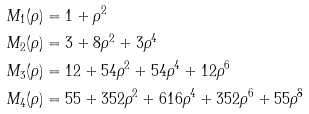Convert formula to latex. <formula><loc_0><loc_0><loc_500><loc_500>M _ { 1 } ( \rho ) & = 1 + \rho ^ { 2 } \\ M _ { 2 } ( \rho ) & = 3 + 8 \rho ^ { 2 } + 3 \rho ^ { 4 } \\ M _ { 3 } ( \rho ) & = 1 2 + 5 4 \rho ^ { 2 } + 5 4 \rho ^ { 4 } + 1 2 \rho ^ { 6 } \\ M _ { 4 } ( \rho ) & = 5 5 + 3 5 2 \rho ^ { 2 } + 6 1 6 \rho ^ { 4 } + 3 5 2 \rho ^ { 6 } + 5 5 \rho ^ { 8 }</formula> 